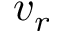Convert formula to latex. <formula><loc_0><loc_0><loc_500><loc_500>v _ { r }</formula> 